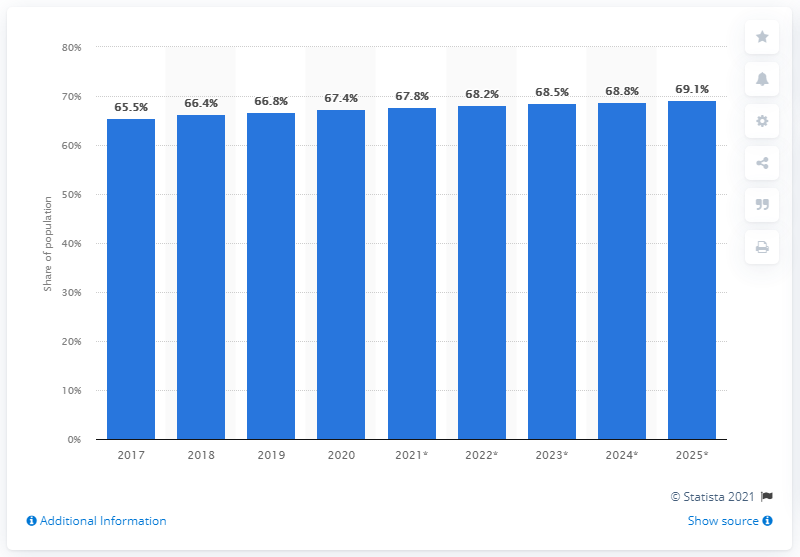List a handful of essential elements in this visual. According to projections, the expected increase in the use of Facebook by 2025 is 69.1%. In 2019, 67.4% of Americans regularly used Facebook. 